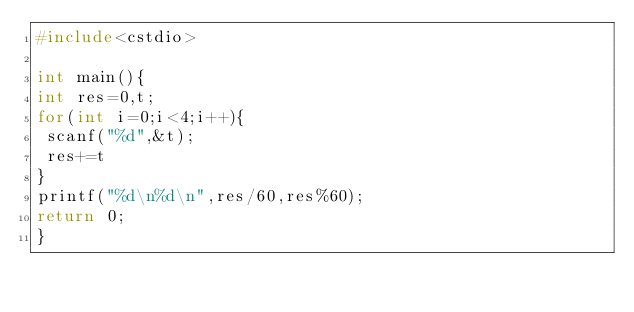Convert code to text. <code><loc_0><loc_0><loc_500><loc_500><_C++_>#include<cstdio>

int main(){
int res=0,t;
for(int i=0;i<4;i++){
 scanf("%d",&t);
 res+=t
}
printf("%d\n%d\n",res/60,res%60);
return 0;
}</code> 